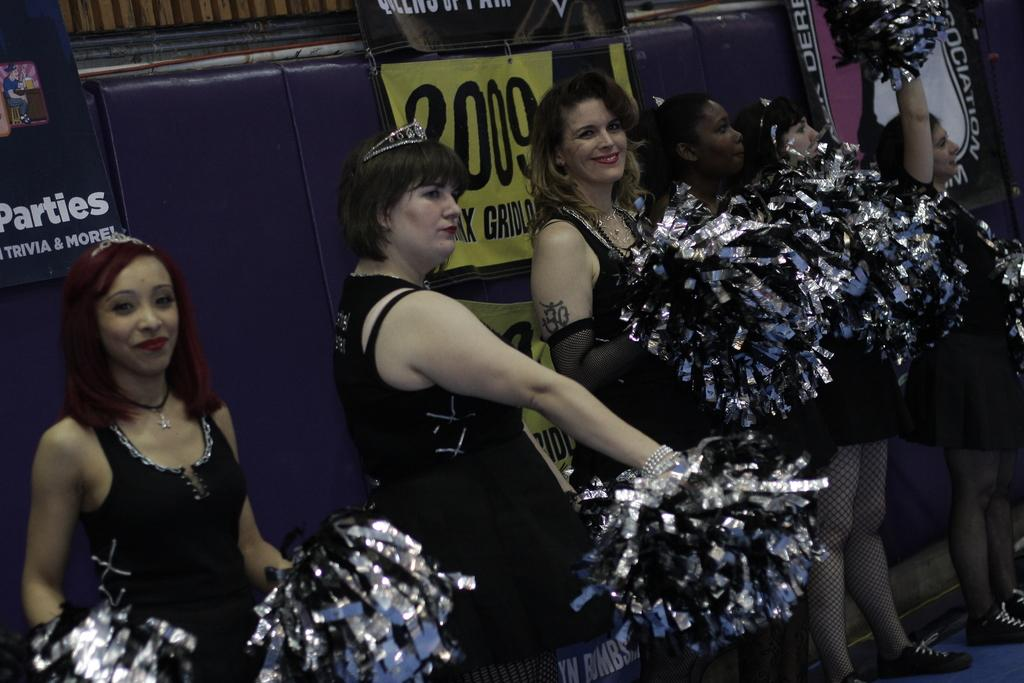What type of group is present in the image? There is a group of cheer girls in the image. How are the cheer girls positioned in the image? The cheer girls are standing in a row. What is behind the cheer girls in the image? The cheer girls are in front of a banner. What are the cheer girls holding in their hands? The cheer girls are holding crafted objects in their hands. Can you describe the stranger's reaction to the smoke in the image? There is no stranger or smoke present in the image. 